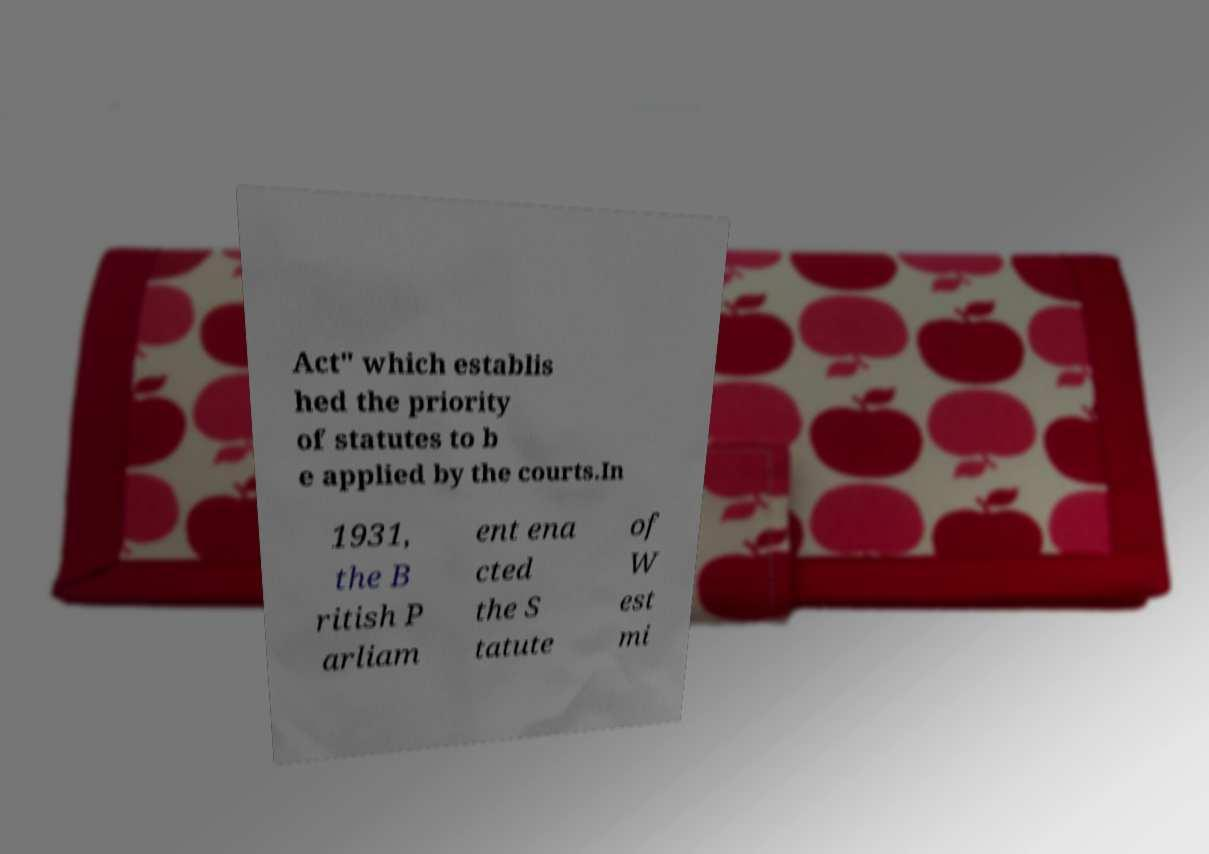Can you accurately transcribe the text from the provided image for me? Act" which establis hed the priority of statutes to b e applied by the courts.In 1931, the B ritish P arliam ent ena cted the S tatute of W est mi 